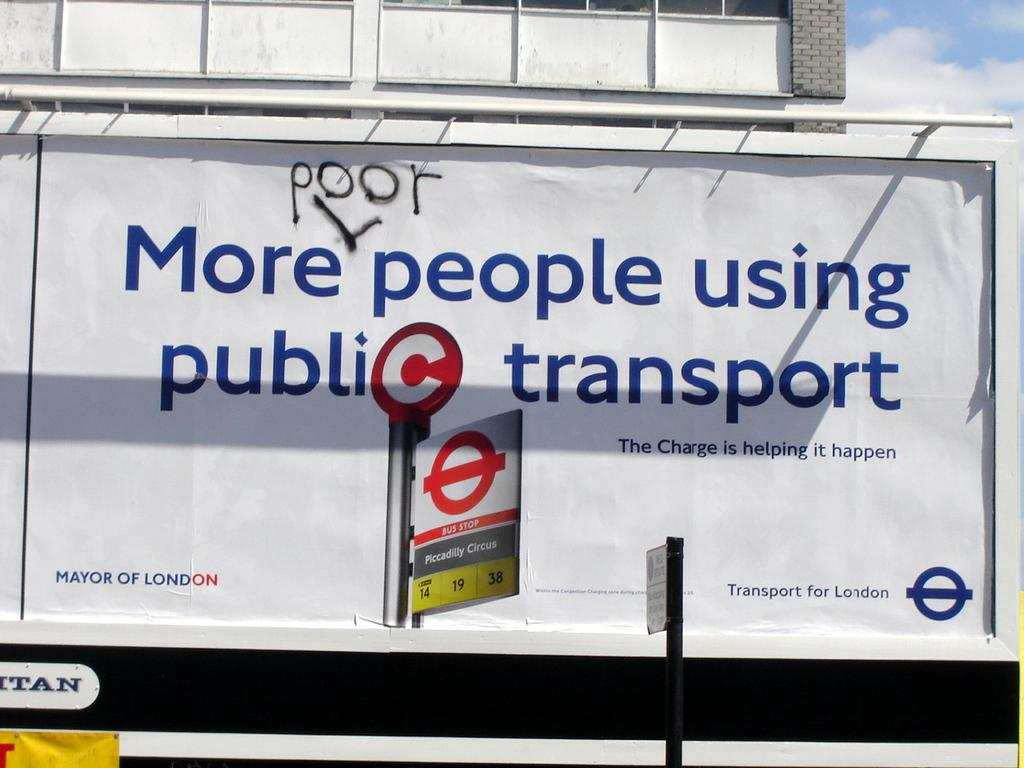<image>
Offer a succinct explanation of the picture presented. An outdoor sign that reads More people using public transport. 